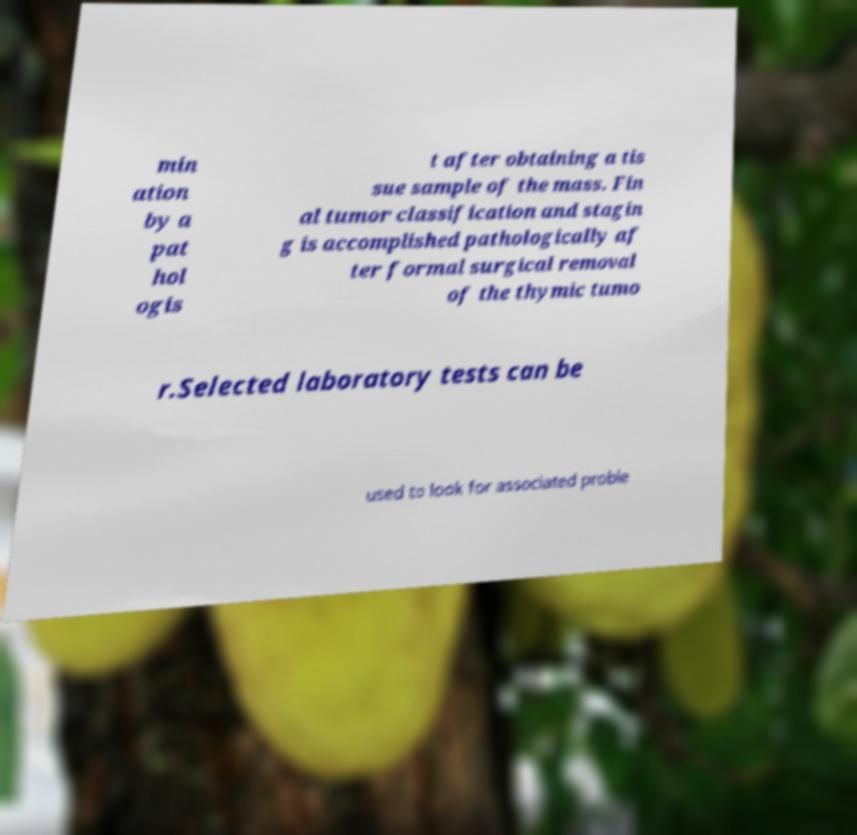Please identify and transcribe the text found in this image. min ation by a pat hol ogis t after obtaining a tis sue sample of the mass. Fin al tumor classification and stagin g is accomplished pathologically af ter formal surgical removal of the thymic tumo r.Selected laboratory tests can be used to look for associated proble 